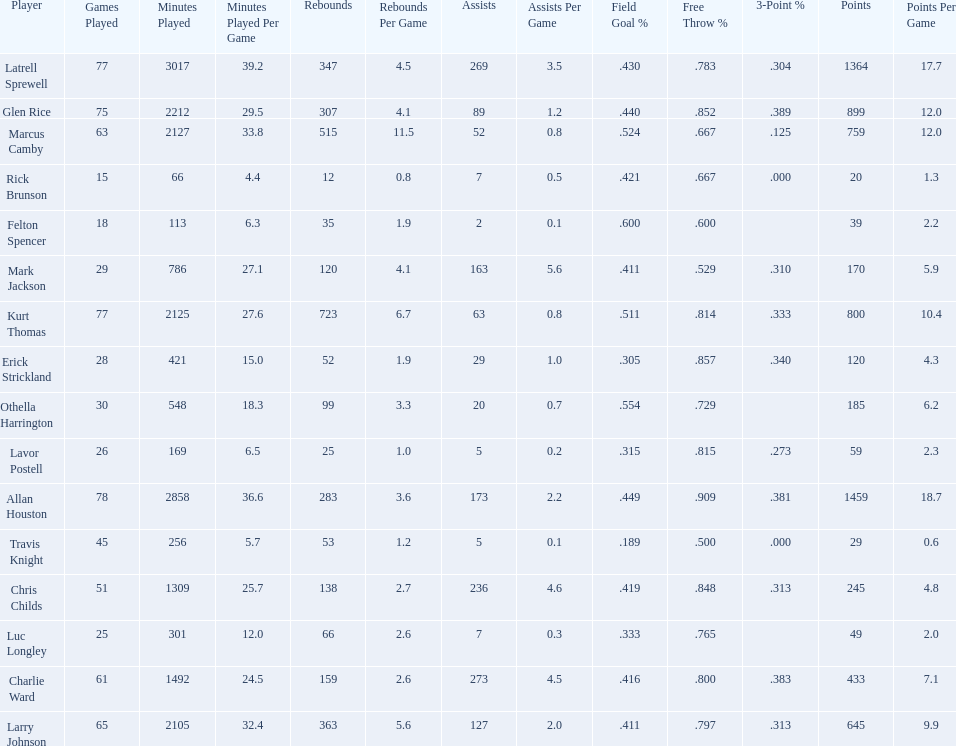How many total points were scored by players averaging over 4 assists per game> 848. 